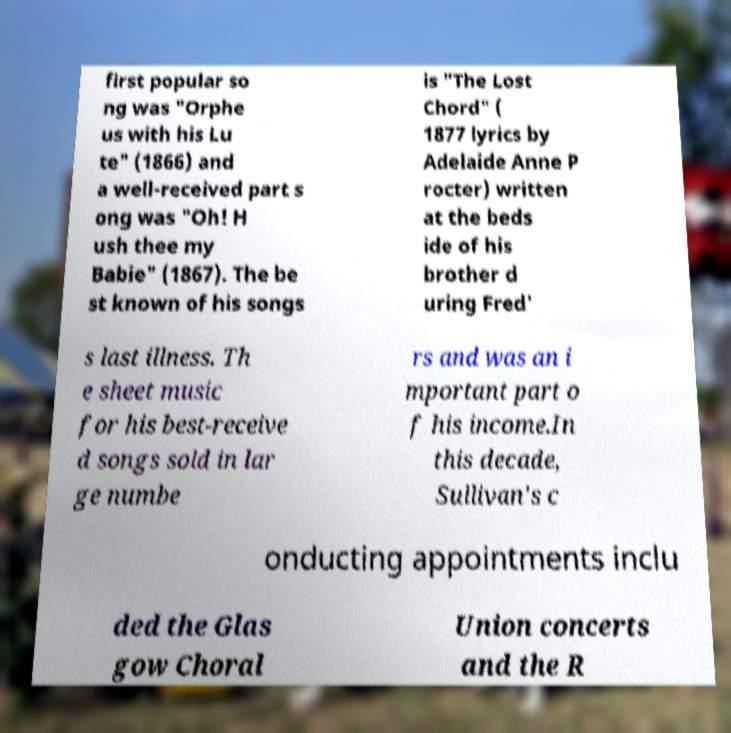What messages or text are displayed in this image? I need them in a readable, typed format. first popular so ng was "Orphe us with his Lu te" (1866) and a well-received part s ong was "Oh! H ush thee my Babie" (1867). The be st known of his songs is "The Lost Chord" ( 1877 lyrics by Adelaide Anne P rocter) written at the beds ide of his brother d uring Fred' s last illness. Th e sheet music for his best-receive d songs sold in lar ge numbe rs and was an i mportant part o f his income.In this decade, Sullivan's c onducting appointments inclu ded the Glas gow Choral Union concerts and the R 